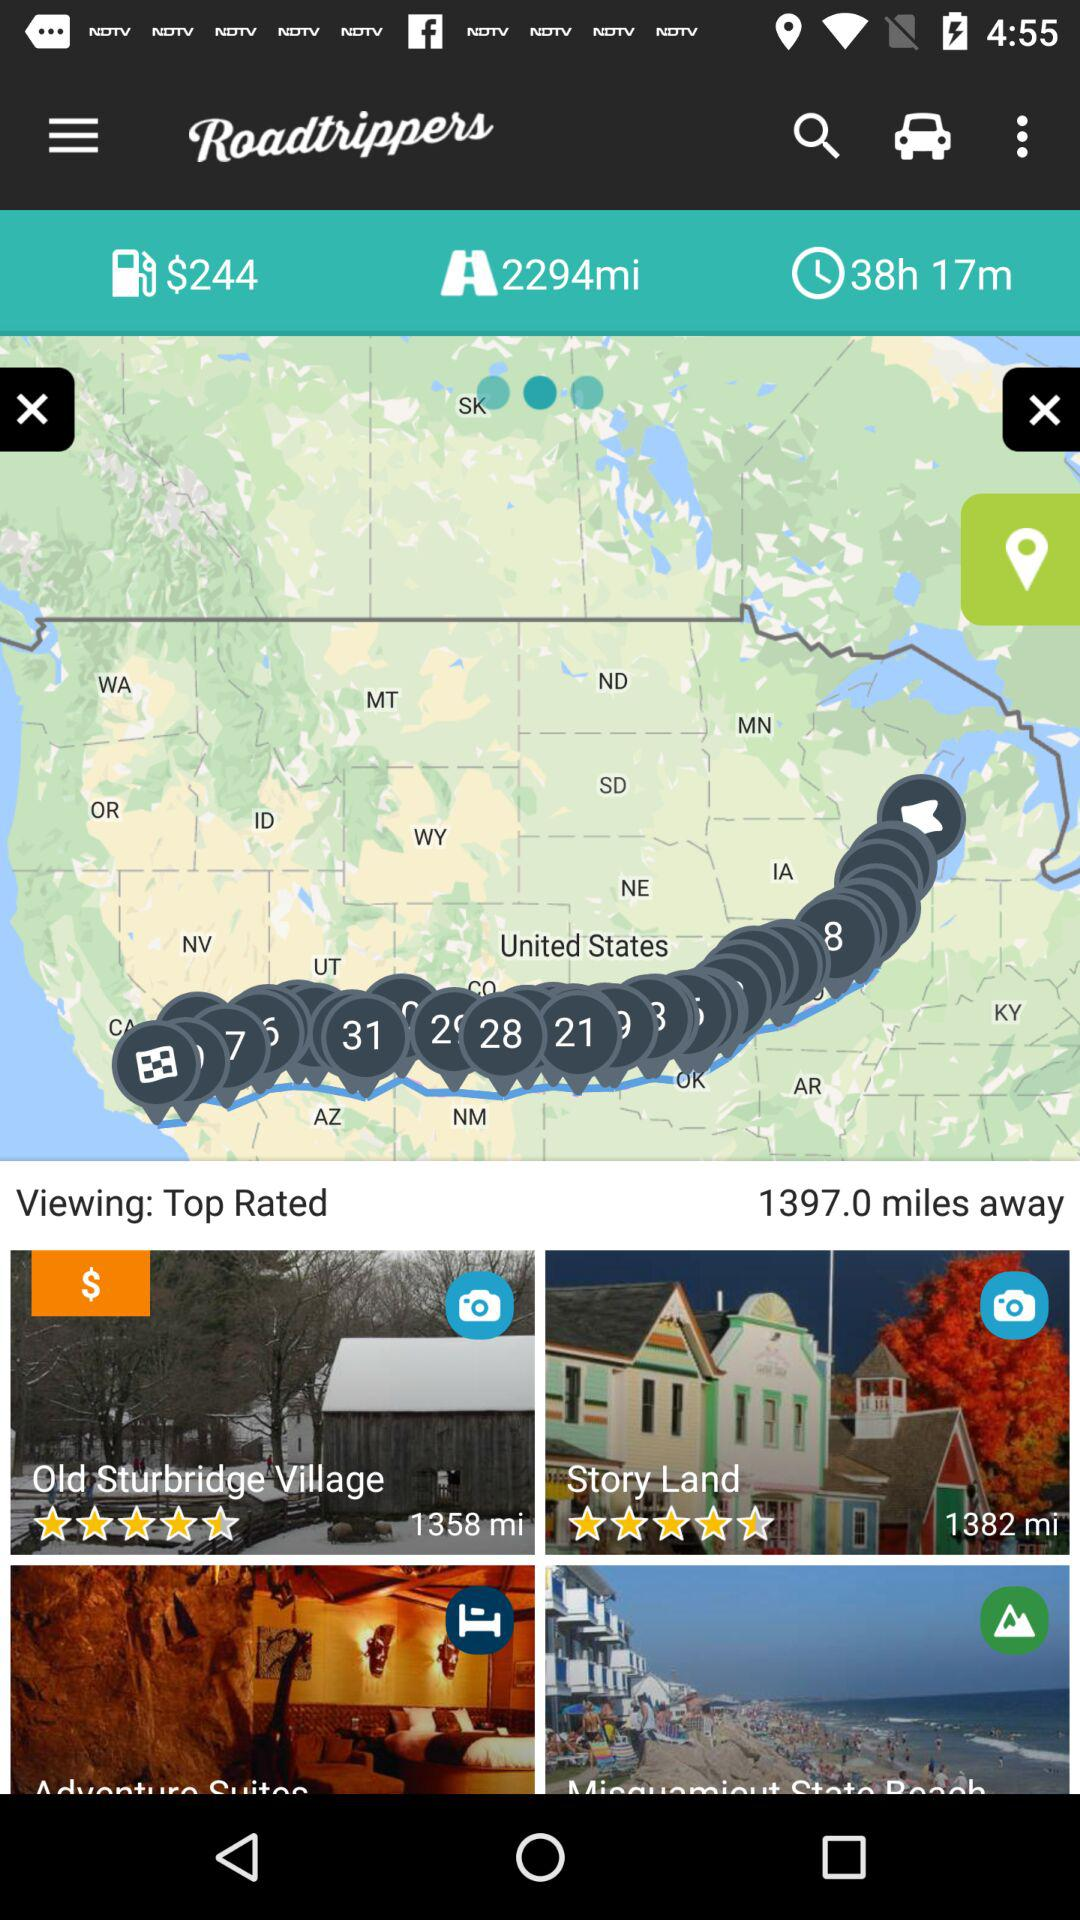What is the total distance in miles from the top-rated place? The total distance in miles from the top-rated place is 2294. 